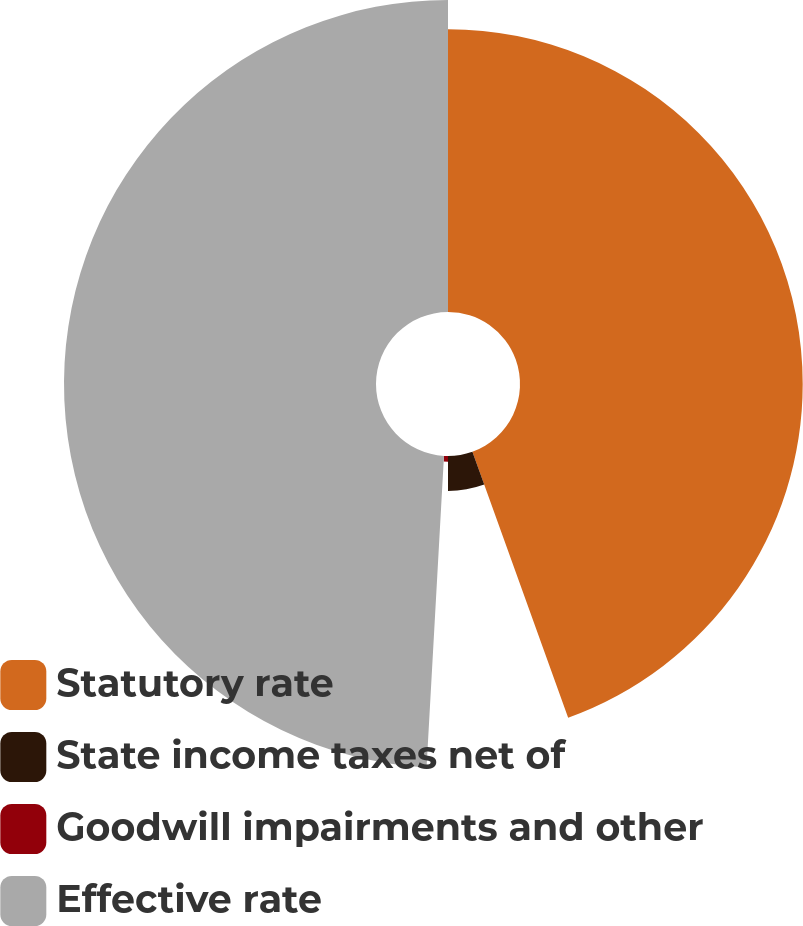<chart> <loc_0><loc_0><loc_500><loc_500><pie_chart><fcel>Statutory rate<fcel>State income taxes net of<fcel>Goodwill impairments and other<fcel>Effective rate<nl><fcel>44.5%<fcel>5.5%<fcel>0.89%<fcel>49.11%<nl></chart> 